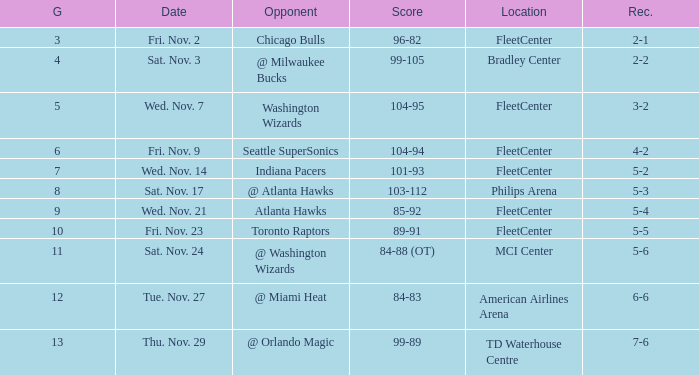What game has a score of 89-91? 10.0. 